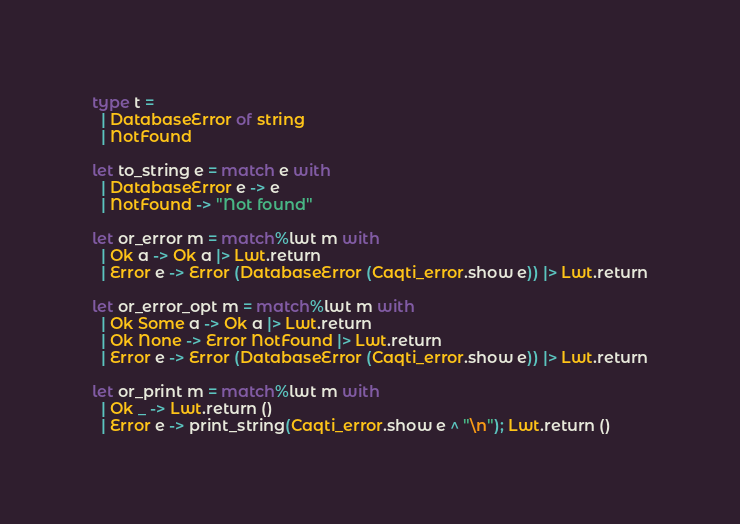Convert code to text. <code><loc_0><loc_0><loc_500><loc_500><_OCaml_>type t =
  | DatabaseError of string
  | NotFound

let to_string e = match e with
  | DatabaseError e -> e
  | NotFound -> "Not found"

let or_error m = match%lwt m with
  | Ok a -> Ok a |> Lwt.return
  | Error e -> Error (DatabaseError (Caqti_error.show e)) |> Lwt.return

let or_error_opt m = match%lwt m with
  | Ok Some a -> Ok a |> Lwt.return
  | Ok None -> Error NotFound |> Lwt.return
  | Error e -> Error (DatabaseError (Caqti_error.show e)) |> Lwt.return

let or_print m = match%lwt m with
  | Ok _ -> Lwt.return ()
  | Error e -> print_string(Caqti_error.show e ^ "\n"); Lwt.return ()</code> 